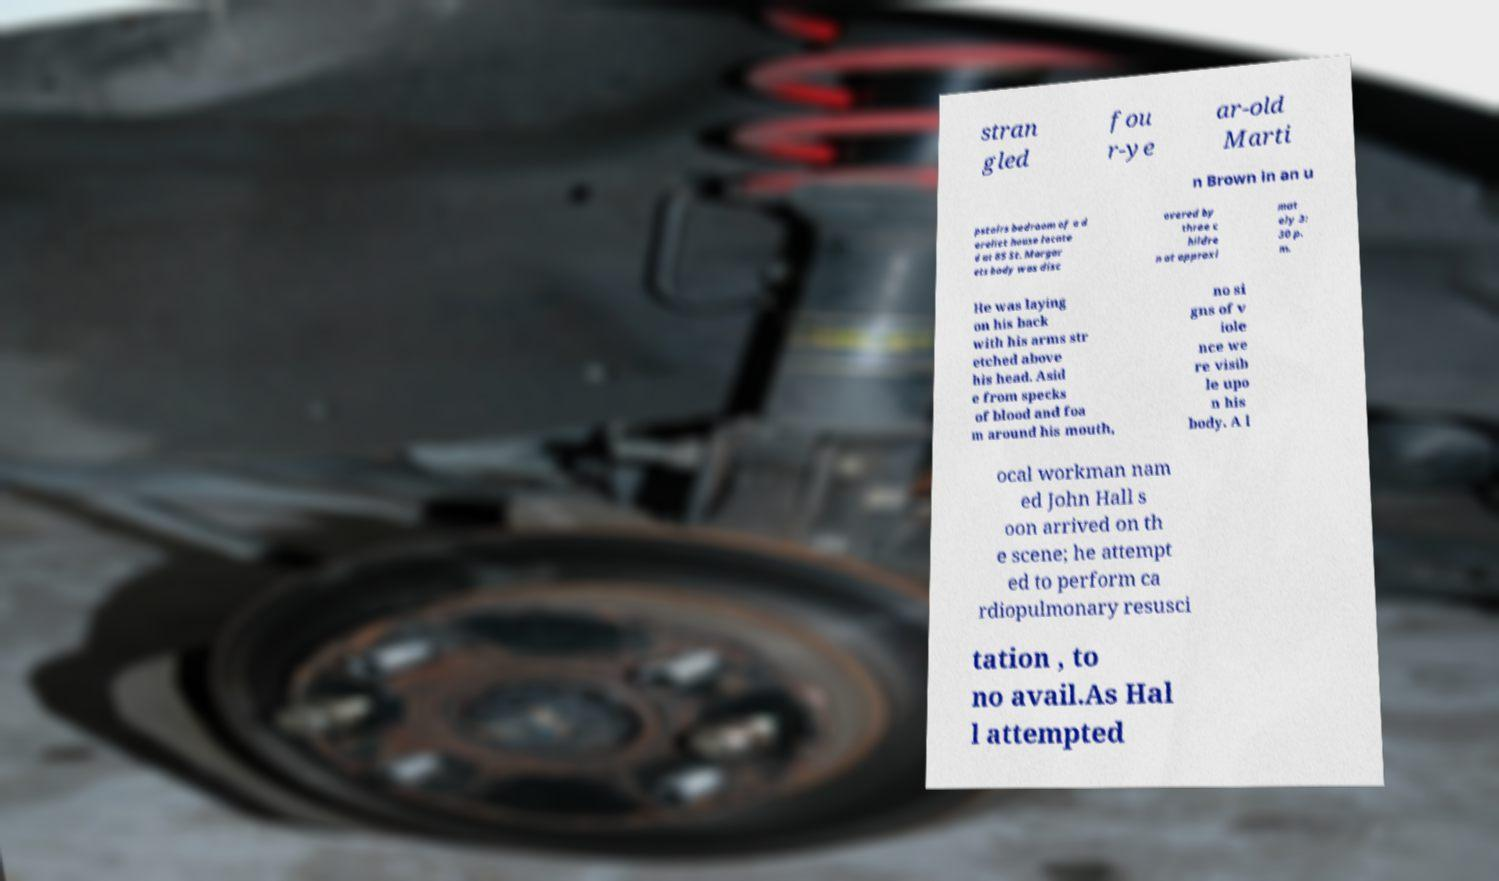For documentation purposes, I need the text within this image transcribed. Could you provide that? stran gled fou r-ye ar-old Marti n Brown in an u pstairs bedroom of a d erelict house locate d at 85 St. Margar ets body was disc overed by three c hildre n at approxi mat ely 3: 30 p. m. He was laying on his back with his arms str etched above his head. Asid e from specks of blood and foa m around his mouth, no si gns of v iole nce we re visib le upo n his body. A l ocal workman nam ed John Hall s oon arrived on th e scene; he attempt ed to perform ca rdiopulmonary resusci tation , to no avail.As Hal l attempted 